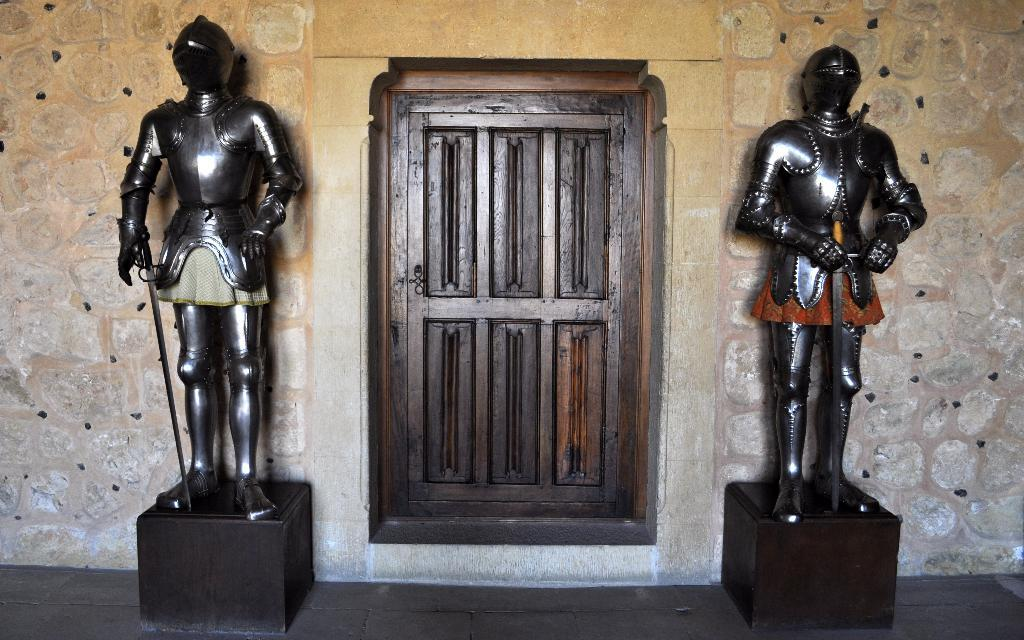What can be seen in the image besides the door in the background? There are two statues in the image. What are the statues holding in their hands? The statues are holding swords in their hands. What is the door attached to in the image? The door is part of a wall. What type of property is being sold by the statues in the image? There is no indication in the image that the statues are selling any property. 